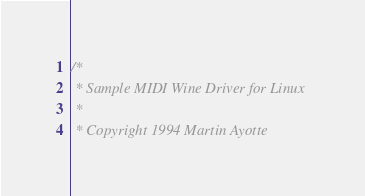Convert code to text. <code><loc_0><loc_0><loc_500><loc_500><_C_>/*
 * Sample MIDI Wine Driver for Linux
 *
 * Copyright 1994 Martin Ayotte</code> 